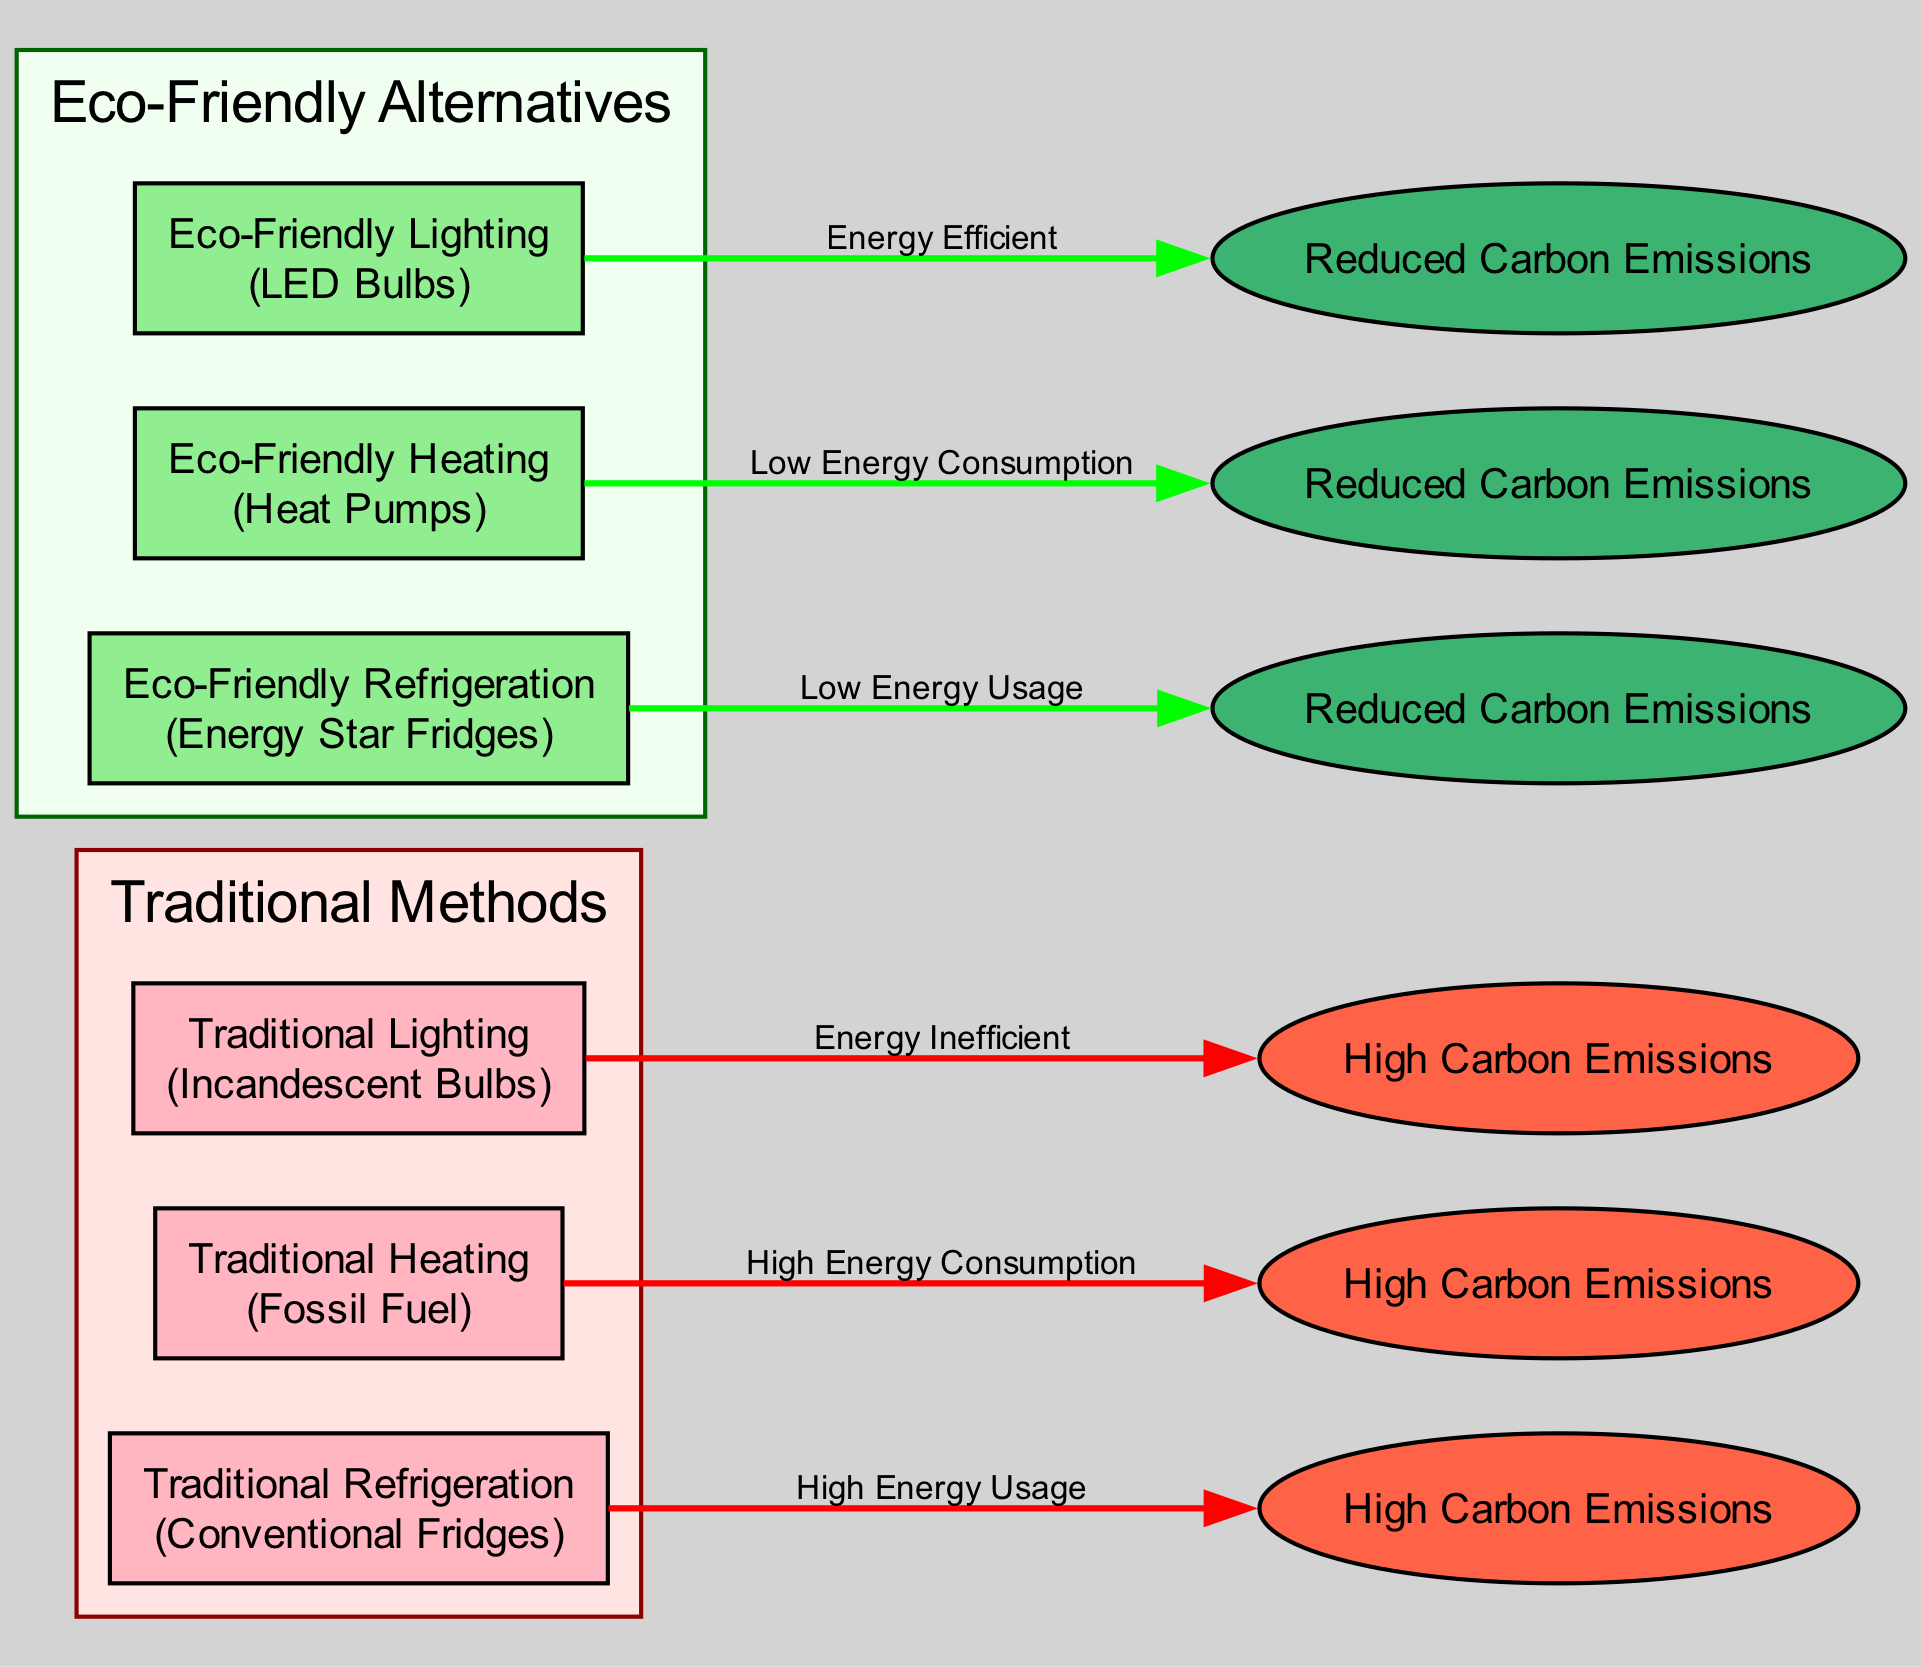What are the traditional lighting options in the diagram? The diagram lists "Traditional Lighting (Incandescent Bulbs)" as one of the nodes representing traditional methods.
Answer: Traditional Lighting (Incandescent Bulbs) How many eco-friendly heating options are presented? The diagram includes one node labeled "Eco-Friendly Heating (Heat Pumps)" in the eco-friendly section.
Answer: 1 What is the relationship between Traditional Heating and its carbon footprint? The diagram shows an edge labeled "High Energy Consumption" flowing from "Traditional Heating (Fossil Fuel)" to "High Carbon Emissions," indicating a direct link.
Answer: High Energy Consumption Which eco-friendly refrigeration option is listed? The node labeled "Eco-Friendly Refrigeration (Energy Star Fridges)" represents the eco-friendly refrigeration method in the diagram.
Answer: Eco-Friendly Refrigeration (Energy Star Fridges) What is the carbon footprint status of Eco-Friendly Lighting? The diagram details "Reduced Carbon Emissions" connected to "Eco-Friendly Lighting (LED Bulbs)," indicating its positive impact.
Answer: Reduced Carbon Emissions Compare the carbon emissions of traditional vs eco-friendly refrigeration. The diagram illustrates "High Carbon Emissions" linked to "Traditional Refrigeration (Conventional Fridges)" and "Reduced Carbon Emissions" linked to "Eco-Friendly Refrigeration (Energy Star Fridges)," highlighting a clear contrast between the two.
Answer: High Carbon Emissions vs Reduced Carbon Emissions What color represents the carbon footprint nodes in the diagram? The diagram uses 'tomato' for nodes displaying high carbon emissions and 'mediumseagreen' for those showing reduced emissions, clearly indicating the environmental impact.
Answer: Tomato for high, Mediumseagreen for reduced Which method is indicated to be energy inefficient according to the diagram? The edge labeled "Energy Inefficient" links "Traditional Lighting (Incandescent Bulbs)" to "High Carbon Emissions," characterizing this method as less preferable.
Answer: Traditional Lighting (Incandescent Bulbs) What implication does the Eco-Friendly Heating method have in terms of energy consumption? The edge labeled "Low Energy Consumption" leading from "Eco-Friendly Heating (Heat Pumps)" to "Reduced Carbon Emissions" demonstrates its positive ecological impact compared to traditional options.
Answer: Low Energy Consumption 